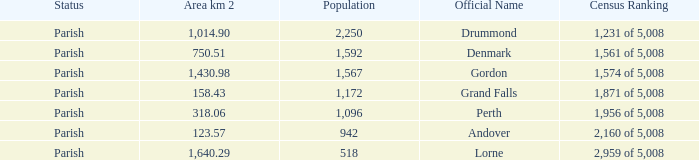Which parish has an area of 750.51? Denmark. 